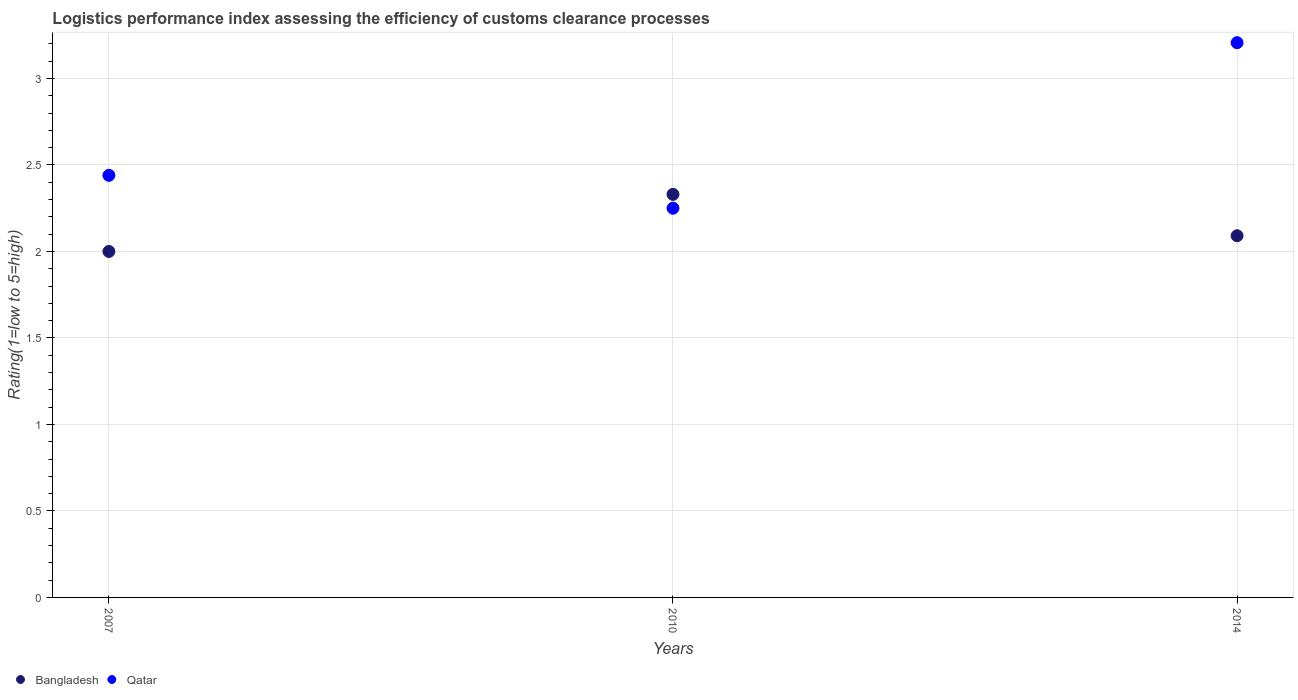How many different coloured dotlines are there?
Your answer should be compact. 2. What is the Logistic performance index in Bangladesh in 2014?
Keep it short and to the point. 2.09. Across all years, what is the maximum Logistic performance index in Bangladesh?
Offer a very short reply. 2.33. Across all years, what is the minimum Logistic performance index in Bangladesh?
Keep it short and to the point. 2. What is the total Logistic performance index in Bangladesh in the graph?
Provide a short and direct response. 6.42. What is the difference between the Logistic performance index in Bangladesh in 2007 and that in 2010?
Your answer should be compact. -0.33. What is the difference between the Logistic performance index in Bangladesh in 2010 and the Logistic performance index in Qatar in 2007?
Your response must be concise. -0.11. What is the average Logistic performance index in Qatar per year?
Provide a succinct answer. 2.63. In the year 2010, what is the difference between the Logistic performance index in Qatar and Logistic performance index in Bangladesh?
Give a very brief answer. -0.08. What is the ratio of the Logistic performance index in Qatar in 2007 to that in 2014?
Your response must be concise. 0.76. Is the difference between the Logistic performance index in Qatar in 2007 and 2010 greater than the difference between the Logistic performance index in Bangladesh in 2007 and 2010?
Your answer should be compact. Yes. What is the difference between the highest and the second highest Logistic performance index in Qatar?
Ensure brevity in your answer.  0.77. What is the difference between the highest and the lowest Logistic performance index in Qatar?
Give a very brief answer. 0.96. Does the Logistic performance index in Qatar monotonically increase over the years?
Give a very brief answer. No. Is the Logistic performance index in Bangladesh strictly less than the Logistic performance index in Qatar over the years?
Your answer should be very brief. No. How many years are there in the graph?
Make the answer very short. 3. What is the difference between two consecutive major ticks on the Y-axis?
Your answer should be very brief. 0.5. Are the values on the major ticks of Y-axis written in scientific E-notation?
Provide a succinct answer. No. Does the graph contain any zero values?
Offer a very short reply. No. Where does the legend appear in the graph?
Ensure brevity in your answer.  Bottom left. How many legend labels are there?
Provide a succinct answer. 2. What is the title of the graph?
Provide a succinct answer. Logistics performance index assessing the efficiency of customs clearance processes. What is the label or title of the X-axis?
Keep it short and to the point. Years. What is the label or title of the Y-axis?
Provide a succinct answer. Rating(1=low to 5=high). What is the Rating(1=low to 5=high) of Qatar in 2007?
Provide a short and direct response. 2.44. What is the Rating(1=low to 5=high) in Bangladesh in 2010?
Offer a very short reply. 2.33. What is the Rating(1=low to 5=high) in Qatar in 2010?
Ensure brevity in your answer.  2.25. What is the Rating(1=low to 5=high) in Bangladesh in 2014?
Offer a very short reply. 2.09. What is the Rating(1=low to 5=high) of Qatar in 2014?
Ensure brevity in your answer.  3.21. Across all years, what is the maximum Rating(1=low to 5=high) of Bangladesh?
Ensure brevity in your answer.  2.33. Across all years, what is the maximum Rating(1=low to 5=high) in Qatar?
Your answer should be compact. 3.21. Across all years, what is the minimum Rating(1=low to 5=high) in Qatar?
Provide a succinct answer. 2.25. What is the total Rating(1=low to 5=high) of Bangladesh in the graph?
Your answer should be compact. 6.42. What is the total Rating(1=low to 5=high) of Qatar in the graph?
Provide a succinct answer. 7.9. What is the difference between the Rating(1=low to 5=high) of Bangladesh in 2007 and that in 2010?
Your response must be concise. -0.33. What is the difference between the Rating(1=low to 5=high) of Qatar in 2007 and that in 2010?
Ensure brevity in your answer.  0.19. What is the difference between the Rating(1=low to 5=high) of Bangladesh in 2007 and that in 2014?
Offer a terse response. -0.09. What is the difference between the Rating(1=low to 5=high) of Qatar in 2007 and that in 2014?
Ensure brevity in your answer.  -0.77. What is the difference between the Rating(1=low to 5=high) in Bangladesh in 2010 and that in 2014?
Your answer should be very brief. 0.24. What is the difference between the Rating(1=low to 5=high) in Qatar in 2010 and that in 2014?
Provide a short and direct response. -0.96. What is the difference between the Rating(1=low to 5=high) in Bangladesh in 2007 and the Rating(1=low to 5=high) in Qatar in 2014?
Your answer should be very brief. -1.21. What is the difference between the Rating(1=low to 5=high) of Bangladesh in 2010 and the Rating(1=low to 5=high) of Qatar in 2014?
Keep it short and to the point. -0.88. What is the average Rating(1=low to 5=high) of Bangladesh per year?
Provide a succinct answer. 2.14. What is the average Rating(1=low to 5=high) in Qatar per year?
Give a very brief answer. 2.63. In the year 2007, what is the difference between the Rating(1=low to 5=high) in Bangladesh and Rating(1=low to 5=high) in Qatar?
Make the answer very short. -0.44. In the year 2010, what is the difference between the Rating(1=low to 5=high) in Bangladesh and Rating(1=low to 5=high) in Qatar?
Offer a very short reply. 0.08. In the year 2014, what is the difference between the Rating(1=low to 5=high) of Bangladesh and Rating(1=low to 5=high) of Qatar?
Provide a succinct answer. -1.12. What is the ratio of the Rating(1=low to 5=high) of Bangladesh in 2007 to that in 2010?
Make the answer very short. 0.86. What is the ratio of the Rating(1=low to 5=high) in Qatar in 2007 to that in 2010?
Your response must be concise. 1.08. What is the ratio of the Rating(1=low to 5=high) in Bangladesh in 2007 to that in 2014?
Offer a very short reply. 0.96. What is the ratio of the Rating(1=low to 5=high) of Qatar in 2007 to that in 2014?
Make the answer very short. 0.76. What is the ratio of the Rating(1=low to 5=high) of Bangladesh in 2010 to that in 2014?
Your answer should be compact. 1.11. What is the ratio of the Rating(1=low to 5=high) of Qatar in 2010 to that in 2014?
Offer a terse response. 0.7. What is the difference between the highest and the second highest Rating(1=low to 5=high) of Bangladesh?
Your response must be concise. 0.24. What is the difference between the highest and the second highest Rating(1=low to 5=high) in Qatar?
Provide a short and direct response. 0.77. What is the difference between the highest and the lowest Rating(1=low to 5=high) of Bangladesh?
Provide a short and direct response. 0.33. What is the difference between the highest and the lowest Rating(1=low to 5=high) of Qatar?
Provide a succinct answer. 0.96. 